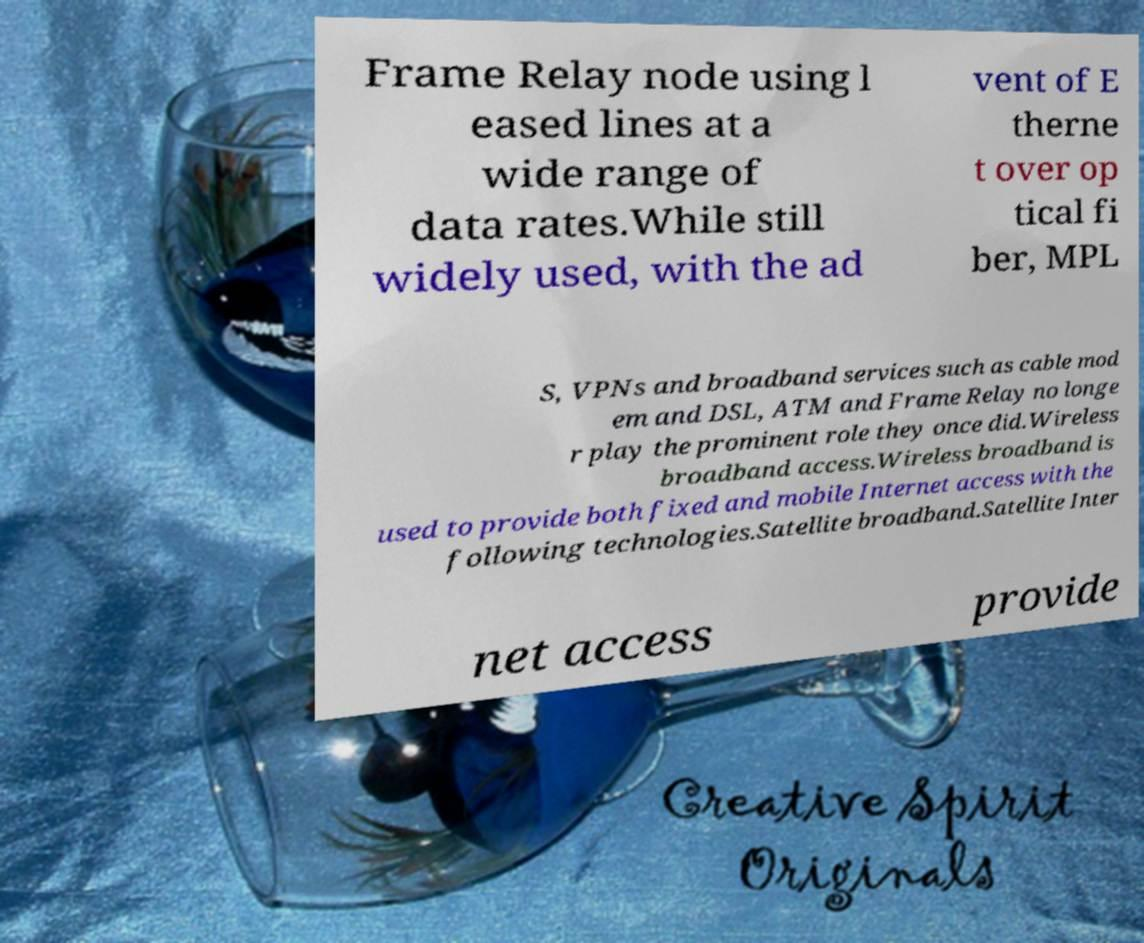I need the written content from this picture converted into text. Can you do that? Frame Relay node using l eased lines at a wide range of data rates.While still widely used, with the ad vent of E therne t over op tical fi ber, MPL S, VPNs and broadband services such as cable mod em and DSL, ATM and Frame Relay no longe r play the prominent role they once did.Wireless broadband access.Wireless broadband is used to provide both fixed and mobile Internet access with the following technologies.Satellite broadband.Satellite Inter net access provide 